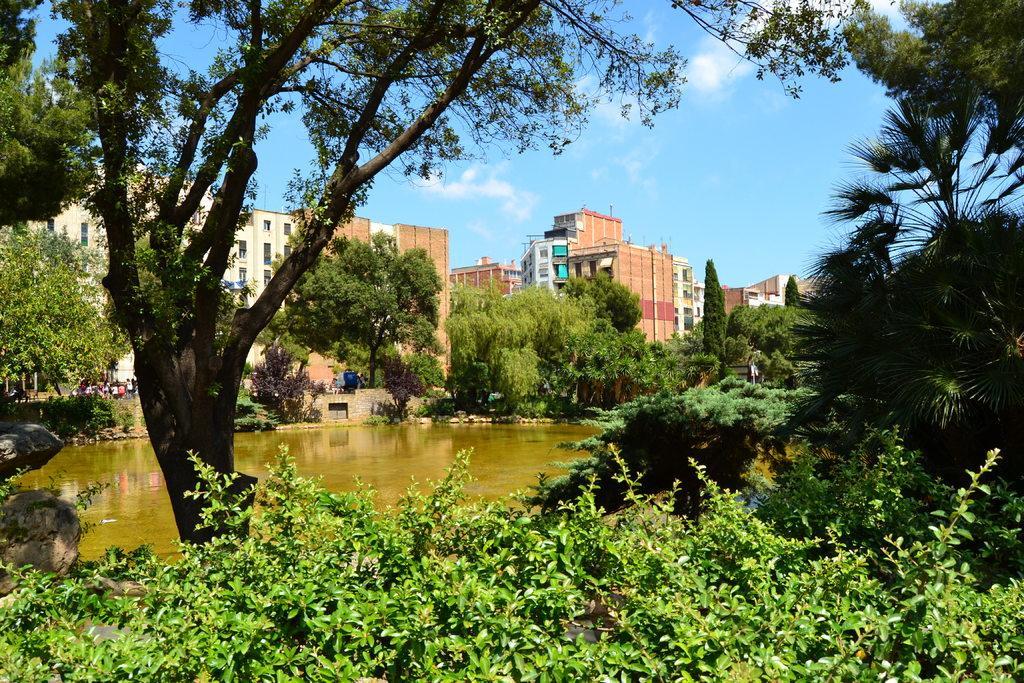How would you summarize this image in a sentence or two? In this picture we can see a few plants at the bottom of the picture. We can see a few stones on the left side. There is water. We can see a few trees, objects and buildings in the background. Sky is blue in color and cloudy. 